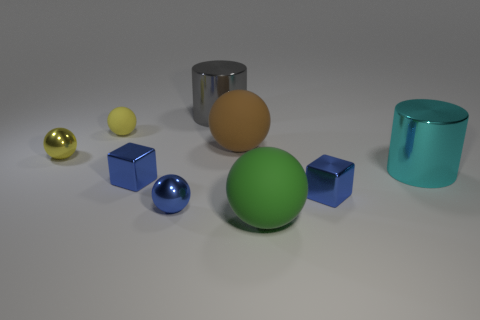There is a cyan shiny thing; how many gray cylinders are left of it?
Provide a succinct answer. 1. Is there a small sphere made of the same material as the green object?
Your response must be concise. Yes. Is the number of cyan things that are left of the large gray shiny cylinder greater than the number of big things on the left side of the green ball?
Provide a succinct answer. No. What size is the yellow rubber sphere?
Your response must be concise. Small. What is the shape of the blue shiny object to the right of the blue metallic sphere?
Ensure brevity in your answer.  Cube. Is the cyan thing the same shape as the brown matte thing?
Your answer should be compact. No. Is the number of small blue metal cubes behind the large cyan metallic cylinder the same as the number of tiny blue things?
Your answer should be very brief. No. What is the shape of the big brown matte object?
Give a very brief answer. Sphere. Is there anything else that is the same color as the tiny matte object?
Your response must be concise. Yes. Is the size of the shiny sphere on the left side of the blue sphere the same as the blue block that is on the right side of the gray thing?
Offer a terse response. Yes. 